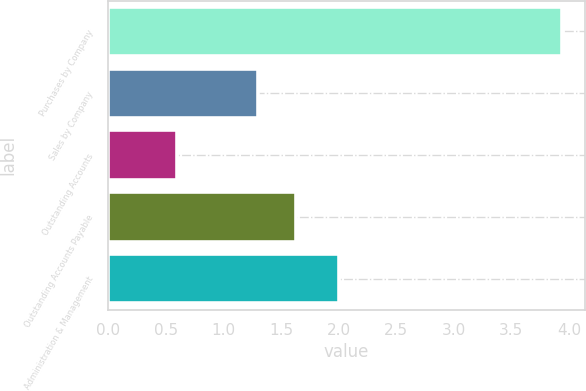Convert chart to OTSL. <chart><loc_0><loc_0><loc_500><loc_500><bar_chart><fcel>Purchases by Company<fcel>Sales by Company<fcel>Outstanding Accounts<fcel>Outstanding Accounts Payable<fcel>Administration & Management<nl><fcel>3.94<fcel>1.3<fcel>0.6<fcel>1.63<fcel>2<nl></chart> 